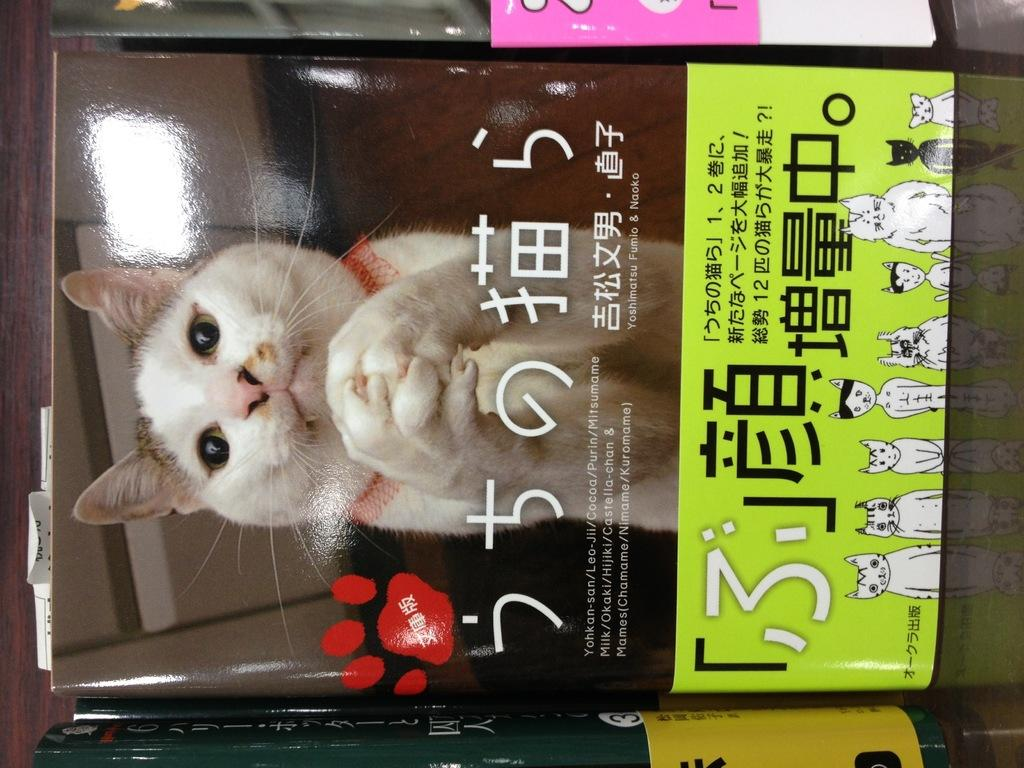What is the main subject in the center of the image? There is a book in the center of the image. What can be seen on the cover of the book? The book has a cat image on it. Are there any other books visible in the image? Yes, there are other books at the top and bottom sides of the image. What type of zipper can be seen on the cat in the image? There is no zipper present on the cat in the image, as it is a cat image on the cover of a book. 